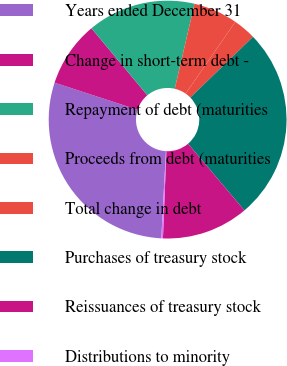Convert chart to OTSL. <chart><loc_0><loc_0><loc_500><loc_500><pie_chart><fcel>Years ended December 31<fcel>Change in short-term debt -<fcel>Repayment of debt (maturities<fcel>Proceeds from debt (maturities<fcel>Total change in debt<fcel>Purchases of treasury stock<fcel>Reissuances of treasury stock<fcel>Distributions to minority<nl><fcel>29.18%<fcel>8.91%<fcel>14.7%<fcel>6.01%<fcel>3.11%<fcel>26.08%<fcel>11.8%<fcel>0.22%<nl></chart> 